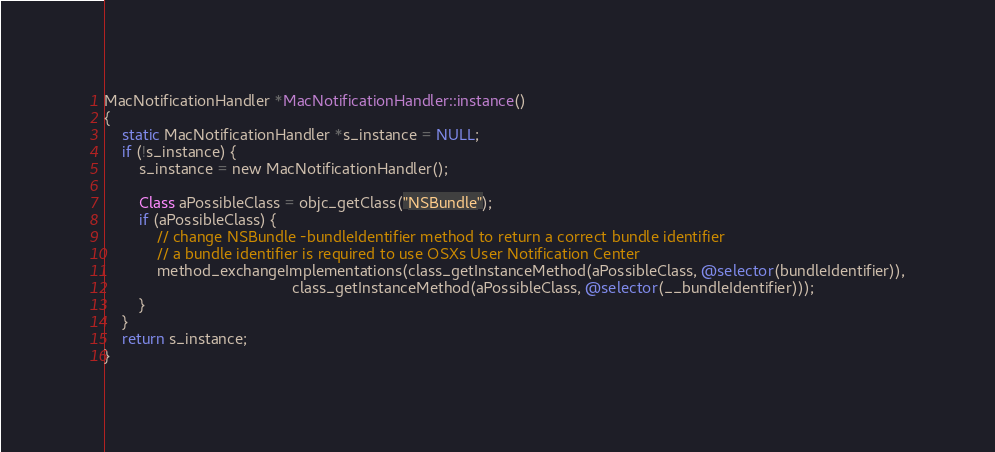<code> <loc_0><loc_0><loc_500><loc_500><_ObjectiveC_>

MacNotificationHandler *MacNotificationHandler::instance()
{
    static MacNotificationHandler *s_instance = NULL;
    if (!s_instance) {
        s_instance = new MacNotificationHandler();

        Class aPossibleClass = objc_getClass("NSBundle");
        if (aPossibleClass) {
            // change NSBundle -bundleIdentifier method to return a correct bundle identifier
            // a bundle identifier is required to use OSXs User Notification Center
            method_exchangeImplementations(class_getInstanceMethod(aPossibleClass, @selector(bundleIdentifier)),
                                           class_getInstanceMethod(aPossibleClass, @selector(__bundleIdentifier)));
        }
    }
    return s_instance;
}
</code> 